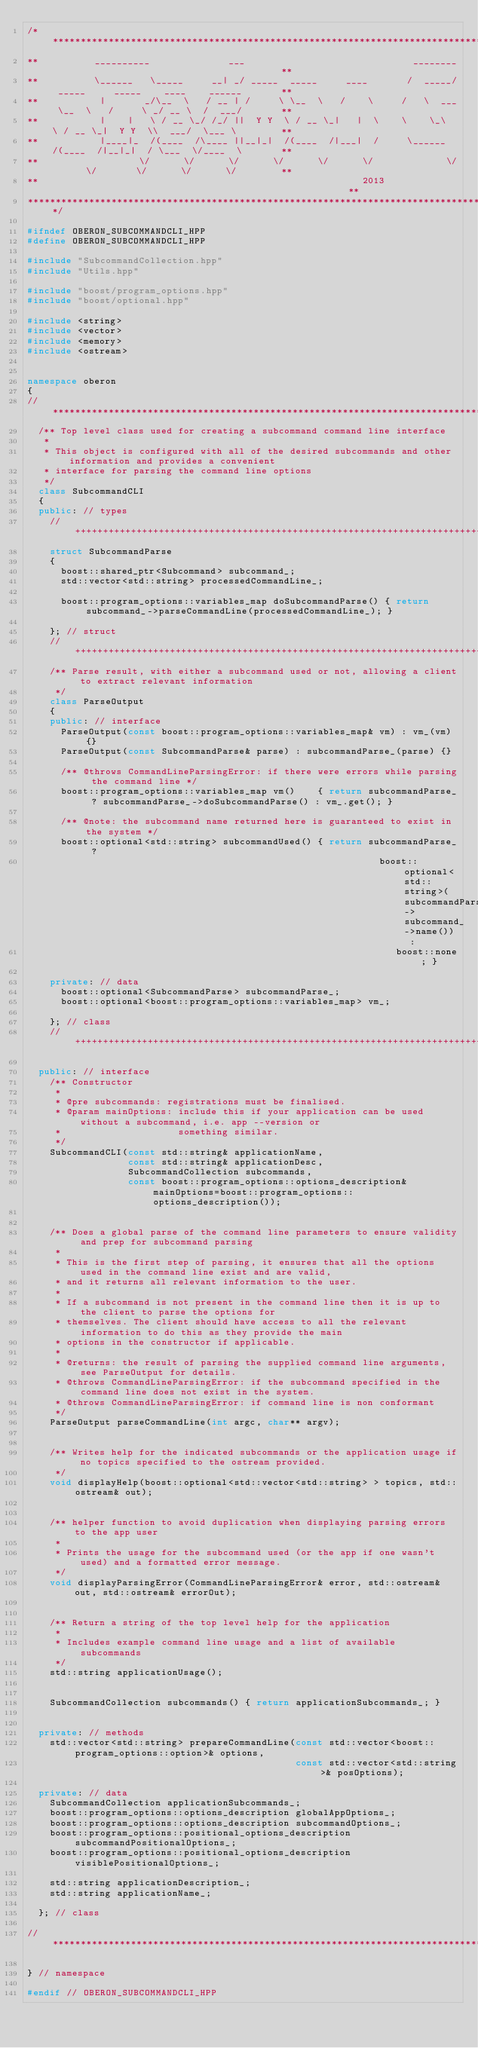Convert code to text. <code><loc_0><loc_0><loc_500><loc_500><_C++_>/***********************************************************************************************************************
**          __________              ___                              ________                                         **
**          \______   \_____     __| _/ _____  _____     ____       /  _____/ _____     _____    ____    ______       **
**           |       _/\__  \   / __ | /     \ \__  \   /    \     /   \  ___ \__  \   /     \ _/ __ \  /  ___/       **
**           |    |   \ / __ \_/ /_/ ||  Y Y  \ / __ \_|   |  \    \    \_\  \ / __ \_|  Y Y  \\  ___/  \___ \        **
**           |____|_  /(____  /\____ ||__|_|  /(____  /|___|  /     \______  /(____  /|__|_|  / \___  \/____  \       **
**                  \/      \/      \/      \/      \/      \/             \/      \/       \/      \/      \/        **
**                                                          2013                                                      **
***********************************************************************************************************************/

#ifndef OBERON_SUBCOMMANDCLI_HPP
#define OBERON_SUBCOMMANDCLI_HPP

#include "SubcommandCollection.hpp"
#include "Utils.hpp"

#include "boost/program_options.hpp"
#include "boost/optional.hpp"

#include <string>
#include <vector>
#include <memory>
#include <ostream>


namespace oberon
{
//**********************************************************************************************************************
  /** Top level class used for creating a subcommand command line interface
   *
   * This object is configured with all of the desired subcommands and other information and provides a convenient
   * interface for parsing the command line options
   */
  class SubcommandCLI
  {
  public: // types
    //++++++++++++++++++++++++++++++++++++++++++++++++++++++++++++++++++++++++++++++++++++++++++++++++++++++++++++++++++
    struct SubcommandParse
    {
      boost::shared_ptr<Subcommand> subcommand_;
      std::vector<std::string> processedCommandLine_;

      boost::program_options::variables_map doSubcommandParse() { return subcommand_->parseCommandLine(processedCommandLine_); }

    }; // struct
    //++++++++++++++++++++++++++++++++++++++++++++++++++++++++++++++++++++++++++++++++++++++++++++++++++++++++++++++++++
    /** Parse result, with either a subcommand used or not, allowing a client to extract relevant information
     */
    class ParseOutput
    {
    public: // interface
      ParseOutput(const boost::program_options::variables_map& vm) : vm_(vm) {}
      ParseOutput(const SubcommandParse& parse) : subcommandParse_(parse) {}

      /** @throws CommandLineParsingError: if there were errors while parsing the command line */
      boost::program_options::variables_map vm()    { return subcommandParse_ ? subcommandParse_->doSubcommandParse() : vm_.get(); }

      /** @note: the subcommand name returned here is guaranteed to exist in the system */
      boost::optional<std::string> subcommandUsed() { return subcommandParse_ ?
                                                               boost::optional<std::string>(subcommandParse_->subcommand_->name()) :
                                                                  boost::none; }

    private: // data
      boost::optional<SubcommandParse> subcommandParse_;
      boost::optional<boost::program_options::variables_map> vm_;

    }; // class
    //++++++++++++++++++++++++++++++++++++++++++++++++++++++++++++++++++++++++++++++++++++++++++++++++++++++++++++++++++

  public: // interface
    /** Constructor
     *
     * @pre subcommands: registrations must be finalised.
     * @param mainOptions: include this if your application can be used without a subcommand, i.e. app --version or
     *                     something similar.
     */
    SubcommandCLI(const std::string& applicationName,
                  const std::string& applicationDesc,
                  SubcommandCollection subcommands,
                  const boost::program_options::options_description& mainOptions=boost::program_options::options_description());


    /** Does a global parse of the command line parameters to ensure validity and prep for subcommand parsing
     *
     * This is the first step of parsing, it ensures that all the options used in the command line exist and are valid,
     * and it returns all relevant information to the user.
     *
     * If a subcommand is not present in the command line then it is up to the client to parse the options for
     * themselves. The client should have access to all the relevant information to do this as they provide the main
     * options in the constructor if applicable.
     *
     * @returns: the result of parsing the supplied command line arguments, see ParseOutput for details.
     * @throws CommandLineParsingError: if the subcommand specified in the command line does not exist in the system.
     * @throws CommandLineParsingError: if command line is non conformant
     */
    ParseOutput parseCommandLine(int argc, char** argv);


    /** Writes help for the indicated subcommands or the application usage if no topics specified to the ostream provided.
     */
    void displayHelp(boost::optional<std::vector<std::string> > topics, std::ostream& out);


    /** helper function to avoid duplication when displaying parsing errors to the app user
     *
     * Prints the usage for the subcommand used (or the app if one wasn't used) and a formatted error message.
     */
    void displayParsingError(CommandLineParsingError& error, std::ostream& out, std::ostream& errorOut);


    /** Return a string of the top level help for the application
     *
     * Includes example command line usage and a list of available subcommands
     */
    std::string applicationUsage();


    SubcommandCollection subcommands() { return applicationSubcommands_; }


  private: // methods
    std::vector<std::string> prepareCommandLine(const std::vector<boost::program_options::option>& options,
                                                const std::vector<std::string>& posOptions);

  private: // data
    SubcommandCollection applicationSubcommands_;
    boost::program_options::options_description globalAppOptions_;
    boost::program_options::options_description subcommandOptions_;
    boost::program_options::positional_options_description subcommandPositionalOptions_;
    boost::program_options::positional_options_description visiblePositionalOptions_;

    std::string applicationDescription_;
    std::string applicationName_;

  }; // class

//**********************************************************************************************************************

} // namespace

#endif // OBERON_SUBCOMMANDCLI_HPP
</code> 